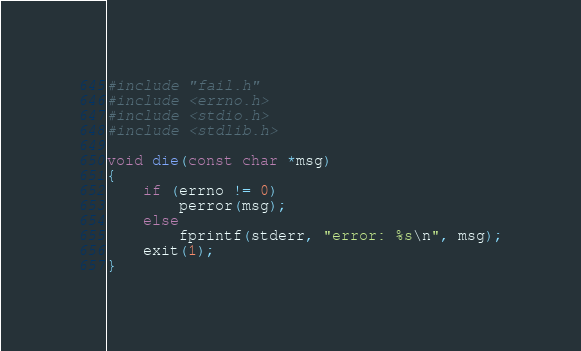<code> <loc_0><loc_0><loc_500><loc_500><_C_>#include "fail.h"
#include <errno.h>
#include <stdio.h>
#include <stdlib.h>

void die(const char *msg)
{
    if (errno != 0) 
        perror(msg);
    else
        fprintf(stderr, "error: %s\n", msg);
    exit(1);
}   
</code> 